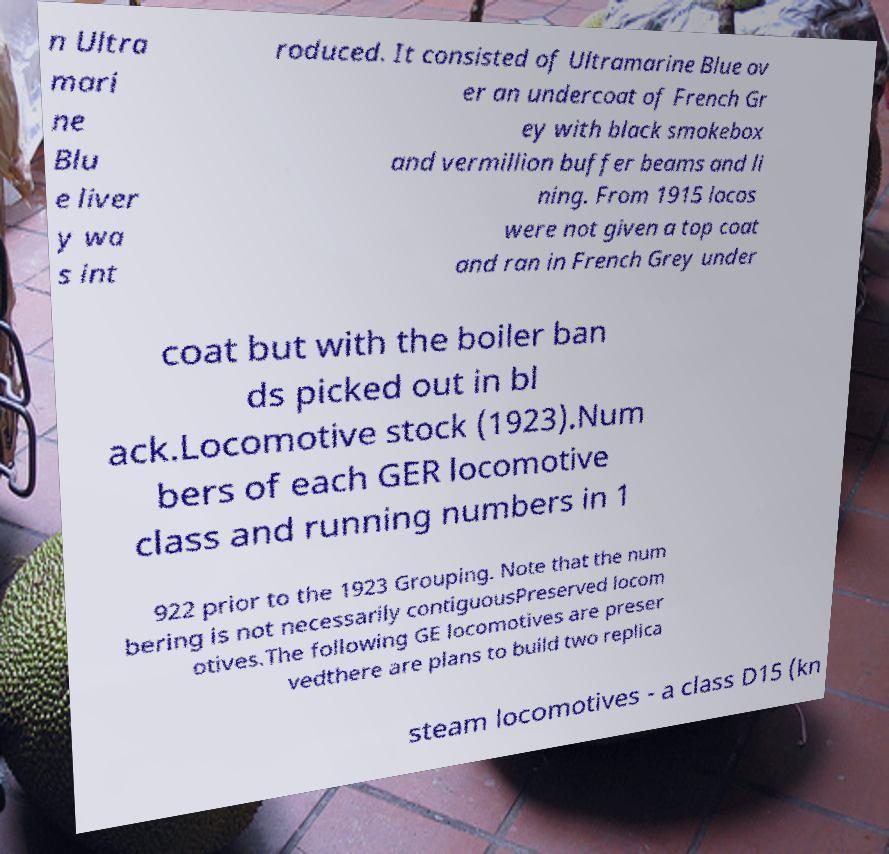Please identify and transcribe the text found in this image. n Ultra mari ne Blu e liver y wa s int roduced. It consisted of Ultramarine Blue ov er an undercoat of French Gr ey with black smokebox and vermillion buffer beams and li ning. From 1915 locos were not given a top coat and ran in French Grey under coat but with the boiler ban ds picked out in bl ack.Locomotive stock (1923).Num bers of each GER locomotive class and running numbers in 1 922 prior to the 1923 Grouping. Note that the num bering is not necessarily contiguousPreserved locom otives.The following GE locomotives are preser vedthere are plans to build two replica steam locomotives - a class D15 (kn 